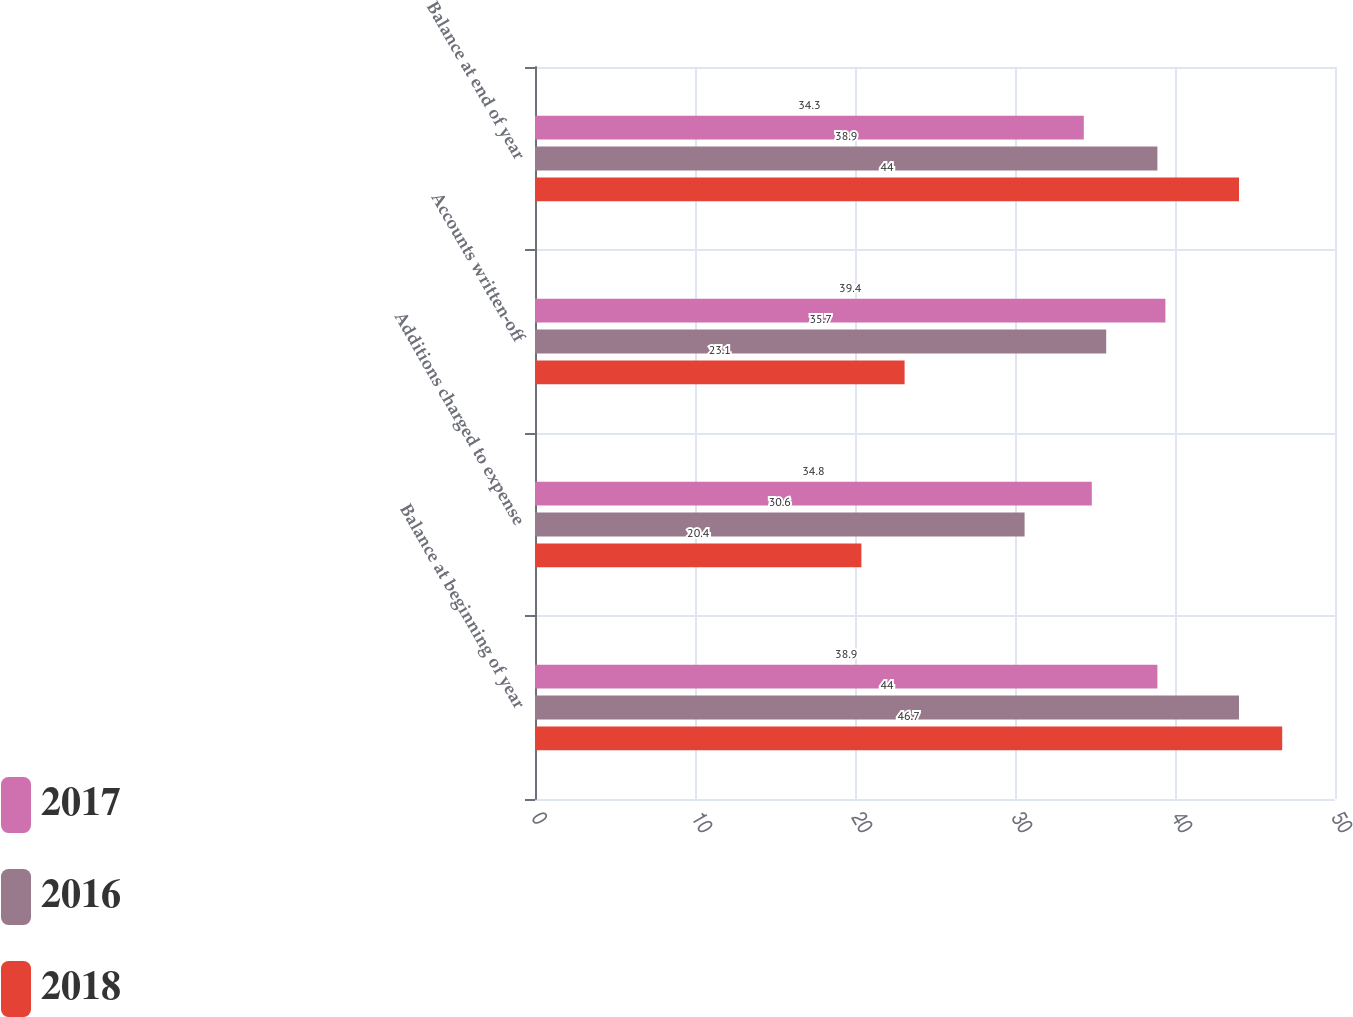<chart> <loc_0><loc_0><loc_500><loc_500><stacked_bar_chart><ecel><fcel>Balance at beginning of year<fcel>Additions charged to expense<fcel>Accounts written-off<fcel>Balance at end of year<nl><fcel>2017<fcel>38.9<fcel>34.8<fcel>39.4<fcel>34.3<nl><fcel>2016<fcel>44<fcel>30.6<fcel>35.7<fcel>38.9<nl><fcel>2018<fcel>46.7<fcel>20.4<fcel>23.1<fcel>44<nl></chart> 